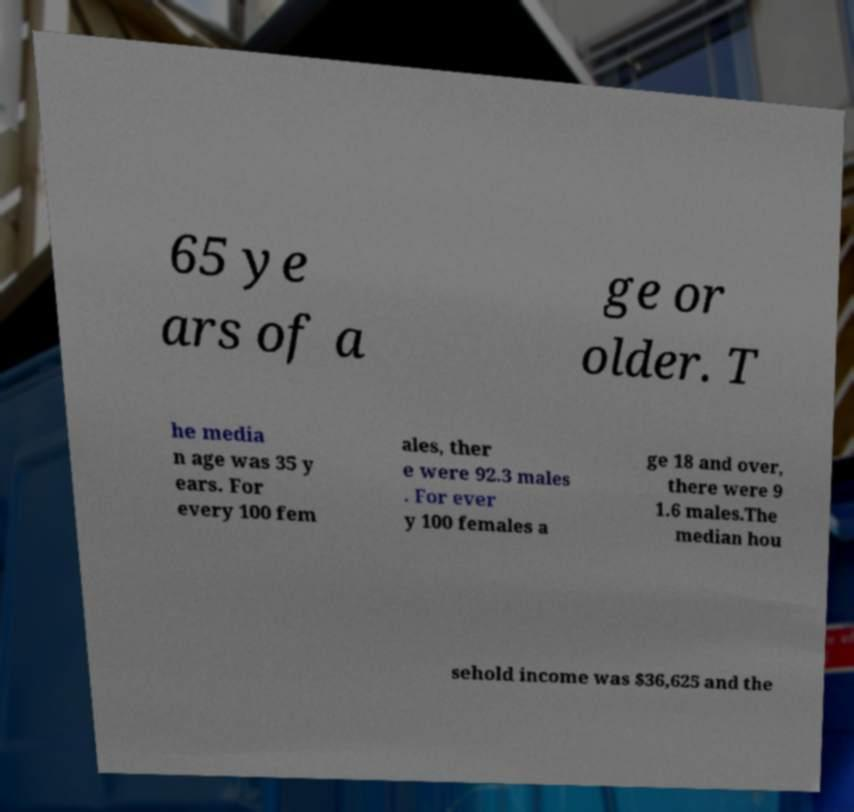Please identify and transcribe the text found in this image. 65 ye ars of a ge or older. T he media n age was 35 y ears. For every 100 fem ales, ther e were 92.3 males . For ever y 100 females a ge 18 and over, there were 9 1.6 males.The median hou sehold income was $36,625 and the 